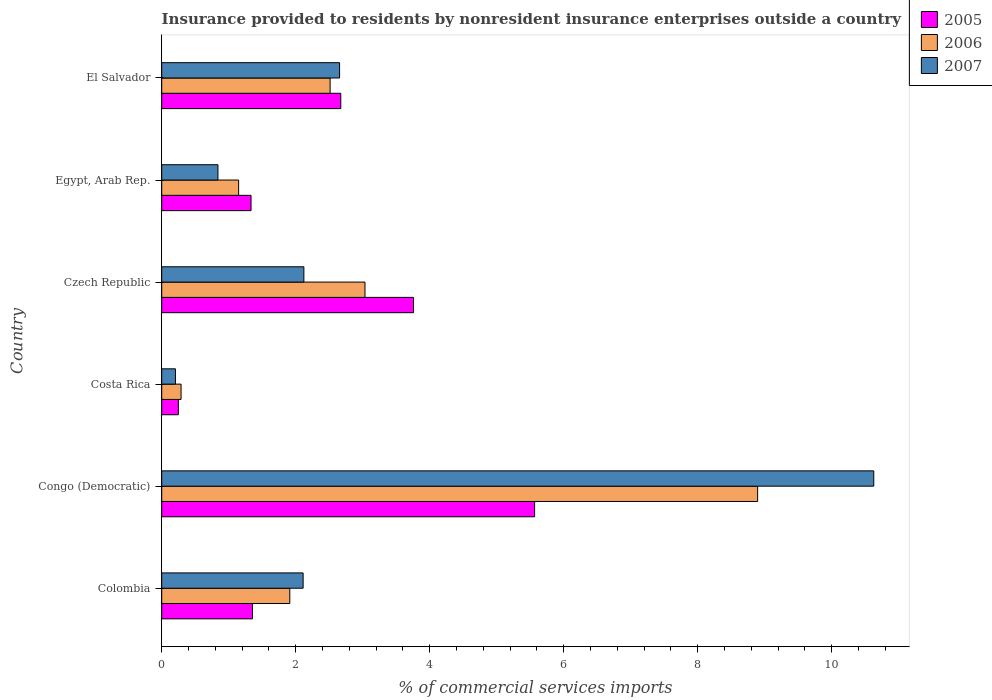How many different coloured bars are there?
Provide a succinct answer. 3. How many groups of bars are there?
Keep it short and to the point. 6. How many bars are there on the 5th tick from the top?
Give a very brief answer. 3. How many bars are there on the 6th tick from the bottom?
Make the answer very short. 3. What is the label of the 5th group of bars from the top?
Keep it short and to the point. Congo (Democratic). What is the Insurance provided to residents in 2005 in Costa Rica?
Keep it short and to the point. 0.25. Across all countries, what is the maximum Insurance provided to residents in 2007?
Your answer should be very brief. 10.63. Across all countries, what is the minimum Insurance provided to residents in 2006?
Ensure brevity in your answer.  0.29. In which country was the Insurance provided to residents in 2007 maximum?
Your answer should be very brief. Congo (Democratic). What is the total Insurance provided to residents in 2005 in the graph?
Offer a very short reply. 14.93. What is the difference between the Insurance provided to residents in 2006 in Colombia and that in Czech Republic?
Give a very brief answer. -1.12. What is the difference between the Insurance provided to residents in 2005 in Czech Republic and the Insurance provided to residents in 2006 in Congo (Democratic)?
Provide a succinct answer. -5.14. What is the average Insurance provided to residents in 2006 per country?
Offer a terse response. 2.96. What is the difference between the Insurance provided to residents in 2007 and Insurance provided to residents in 2006 in Egypt, Arab Rep.?
Ensure brevity in your answer.  -0.31. In how many countries, is the Insurance provided to residents in 2006 greater than 3.6 %?
Provide a short and direct response. 1. What is the ratio of the Insurance provided to residents in 2006 in Congo (Democratic) to that in El Salvador?
Provide a short and direct response. 3.54. What is the difference between the highest and the second highest Insurance provided to residents in 2006?
Give a very brief answer. 5.86. What is the difference between the highest and the lowest Insurance provided to residents in 2007?
Your answer should be compact. 10.42. In how many countries, is the Insurance provided to residents in 2005 greater than the average Insurance provided to residents in 2005 taken over all countries?
Provide a succinct answer. 3. What does the 2nd bar from the top in Egypt, Arab Rep. represents?
Provide a succinct answer. 2006. How many bars are there?
Make the answer very short. 18. How many countries are there in the graph?
Keep it short and to the point. 6. What is the difference between two consecutive major ticks on the X-axis?
Offer a terse response. 2. Are the values on the major ticks of X-axis written in scientific E-notation?
Provide a succinct answer. No. Does the graph contain grids?
Your response must be concise. No. Where does the legend appear in the graph?
Provide a succinct answer. Top right. How are the legend labels stacked?
Offer a very short reply. Vertical. What is the title of the graph?
Offer a very short reply. Insurance provided to residents by nonresident insurance enterprises outside a country. Does "1961" appear as one of the legend labels in the graph?
Your answer should be very brief. No. What is the label or title of the X-axis?
Your answer should be very brief. % of commercial services imports. What is the label or title of the Y-axis?
Provide a short and direct response. Country. What is the % of commercial services imports of 2005 in Colombia?
Your answer should be compact. 1.35. What is the % of commercial services imports of 2006 in Colombia?
Give a very brief answer. 1.91. What is the % of commercial services imports of 2007 in Colombia?
Ensure brevity in your answer.  2.11. What is the % of commercial services imports of 2005 in Congo (Democratic)?
Make the answer very short. 5.57. What is the % of commercial services imports in 2006 in Congo (Democratic)?
Make the answer very short. 8.89. What is the % of commercial services imports of 2007 in Congo (Democratic)?
Ensure brevity in your answer.  10.63. What is the % of commercial services imports of 2005 in Costa Rica?
Your response must be concise. 0.25. What is the % of commercial services imports of 2006 in Costa Rica?
Make the answer very short. 0.29. What is the % of commercial services imports of 2007 in Costa Rica?
Ensure brevity in your answer.  0.2. What is the % of commercial services imports in 2005 in Czech Republic?
Provide a short and direct response. 3.76. What is the % of commercial services imports in 2006 in Czech Republic?
Ensure brevity in your answer.  3.03. What is the % of commercial services imports in 2007 in Czech Republic?
Your answer should be very brief. 2.12. What is the % of commercial services imports of 2005 in Egypt, Arab Rep.?
Give a very brief answer. 1.33. What is the % of commercial services imports in 2006 in Egypt, Arab Rep.?
Make the answer very short. 1.15. What is the % of commercial services imports of 2007 in Egypt, Arab Rep.?
Your answer should be compact. 0.84. What is the % of commercial services imports in 2005 in El Salvador?
Your answer should be compact. 2.67. What is the % of commercial services imports in 2006 in El Salvador?
Provide a succinct answer. 2.51. What is the % of commercial services imports of 2007 in El Salvador?
Offer a very short reply. 2.65. Across all countries, what is the maximum % of commercial services imports of 2005?
Ensure brevity in your answer.  5.57. Across all countries, what is the maximum % of commercial services imports of 2006?
Your answer should be compact. 8.89. Across all countries, what is the maximum % of commercial services imports in 2007?
Offer a terse response. 10.63. Across all countries, what is the minimum % of commercial services imports in 2005?
Offer a very short reply. 0.25. Across all countries, what is the minimum % of commercial services imports of 2006?
Provide a succinct answer. 0.29. Across all countries, what is the minimum % of commercial services imports of 2007?
Provide a succinct answer. 0.2. What is the total % of commercial services imports in 2005 in the graph?
Offer a very short reply. 14.93. What is the total % of commercial services imports in 2006 in the graph?
Provide a short and direct response. 17.79. What is the total % of commercial services imports in 2007 in the graph?
Make the answer very short. 18.56. What is the difference between the % of commercial services imports of 2005 in Colombia and that in Congo (Democratic)?
Provide a succinct answer. -4.21. What is the difference between the % of commercial services imports in 2006 in Colombia and that in Congo (Democratic)?
Ensure brevity in your answer.  -6.98. What is the difference between the % of commercial services imports in 2007 in Colombia and that in Congo (Democratic)?
Offer a very short reply. -8.52. What is the difference between the % of commercial services imports in 2005 in Colombia and that in Costa Rica?
Provide a short and direct response. 1.11. What is the difference between the % of commercial services imports of 2006 in Colombia and that in Costa Rica?
Offer a very short reply. 1.62. What is the difference between the % of commercial services imports of 2007 in Colombia and that in Costa Rica?
Offer a very short reply. 1.91. What is the difference between the % of commercial services imports in 2005 in Colombia and that in Czech Republic?
Keep it short and to the point. -2.4. What is the difference between the % of commercial services imports of 2006 in Colombia and that in Czech Republic?
Your answer should be very brief. -1.12. What is the difference between the % of commercial services imports of 2007 in Colombia and that in Czech Republic?
Your answer should be compact. -0.01. What is the difference between the % of commercial services imports in 2005 in Colombia and that in Egypt, Arab Rep.?
Provide a succinct answer. 0.02. What is the difference between the % of commercial services imports of 2006 in Colombia and that in Egypt, Arab Rep.?
Your response must be concise. 0.76. What is the difference between the % of commercial services imports in 2007 in Colombia and that in Egypt, Arab Rep.?
Make the answer very short. 1.27. What is the difference between the % of commercial services imports of 2005 in Colombia and that in El Salvador?
Keep it short and to the point. -1.32. What is the difference between the % of commercial services imports of 2006 in Colombia and that in El Salvador?
Provide a succinct answer. -0.6. What is the difference between the % of commercial services imports of 2007 in Colombia and that in El Salvador?
Make the answer very short. -0.54. What is the difference between the % of commercial services imports in 2005 in Congo (Democratic) and that in Costa Rica?
Offer a terse response. 5.32. What is the difference between the % of commercial services imports of 2006 in Congo (Democratic) and that in Costa Rica?
Ensure brevity in your answer.  8.6. What is the difference between the % of commercial services imports of 2007 in Congo (Democratic) and that in Costa Rica?
Your answer should be compact. 10.42. What is the difference between the % of commercial services imports in 2005 in Congo (Democratic) and that in Czech Republic?
Keep it short and to the point. 1.81. What is the difference between the % of commercial services imports of 2006 in Congo (Democratic) and that in Czech Republic?
Provide a short and direct response. 5.86. What is the difference between the % of commercial services imports in 2007 in Congo (Democratic) and that in Czech Republic?
Your answer should be very brief. 8.51. What is the difference between the % of commercial services imports in 2005 in Congo (Democratic) and that in Egypt, Arab Rep.?
Provide a succinct answer. 4.23. What is the difference between the % of commercial services imports in 2006 in Congo (Democratic) and that in Egypt, Arab Rep.?
Your response must be concise. 7.75. What is the difference between the % of commercial services imports in 2007 in Congo (Democratic) and that in Egypt, Arab Rep.?
Provide a succinct answer. 9.79. What is the difference between the % of commercial services imports of 2005 in Congo (Democratic) and that in El Salvador?
Give a very brief answer. 2.89. What is the difference between the % of commercial services imports of 2006 in Congo (Democratic) and that in El Salvador?
Your response must be concise. 6.38. What is the difference between the % of commercial services imports of 2007 in Congo (Democratic) and that in El Salvador?
Keep it short and to the point. 7.97. What is the difference between the % of commercial services imports of 2005 in Costa Rica and that in Czech Republic?
Offer a very short reply. -3.51. What is the difference between the % of commercial services imports in 2006 in Costa Rica and that in Czech Republic?
Your answer should be compact. -2.75. What is the difference between the % of commercial services imports of 2007 in Costa Rica and that in Czech Republic?
Give a very brief answer. -1.92. What is the difference between the % of commercial services imports in 2005 in Costa Rica and that in Egypt, Arab Rep.?
Make the answer very short. -1.08. What is the difference between the % of commercial services imports of 2006 in Costa Rica and that in Egypt, Arab Rep.?
Provide a succinct answer. -0.86. What is the difference between the % of commercial services imports in 2007 in Costa Rica and that in Egypt, Arab Rep.?
Your answer should be very brief. -0.63. What is the difference between the % of commercial services imports in 2005 in Costa Rica and that in El Salvador?
Ensure brevity in your answer.  -2.42. What is the difference between the % of commercial services imports in 2006 in Costa Rica and that in El Salvador?
Your answer should be compact. -2.22. What is the difference between the % of commercial services imports of 2007 in Costa Rica and that in El Salvador?
Keep it short and to the point. -2.45. What is the difference between the % of commercial services imports in 2005 in Czech Republic and that in Egypt, Arab Rep.?
Provide a succinct answer. 2.42. What is the difference between the % of commercial services imports of 2006 in Czech Republic and that in Egypt, Arab Rep.?
Offer a very short reply. 1.89. What is the difference between the % of commercial services imports of 2007 in Czech Republic and that in Egypt, Arab Rep.?
Make the answer very short. 1.28. What is the difference between the % of commercial services imports of 2005 in Czech Republic and that in El Salvador?
Ensure brevity in your answer.  1.09. What is the difference between the % of commercial services imports in 2006 in Czech Republic and that in El Salvador?
Your answer should be very brief. 0.52. What is the difference between the % of commercial services imports in 2007 in Czech Republic and that in El Salvador?
Your answer should be very brief. -0.53. What is the difference between the % of commercial services imports of 2005 in Egypt, Arab Rep. and that in El Salvador?
Ensure brevity in your answer.  -1.34. What is the difference between the % of commercial services imports in 2006 in Egypt, Arab Rep. and that in El Salvador?
Your answer should be compact. -1.37. What is the difference between the % of commercial services imports in 2007 in Egypt, Arab Rep. and that in El Salvador?
Your answer should be compact. -1.82. What is the difference between the % of commercial services imports of 2005 in Colombia and the % of commercial services imports of 2006 in Congo (Democratic)?
Provide a short and direct response. -7.54. What is the difference between the % of commercial services imports of 2005 in Colombia and the % of commercial services imports of 2007 in Congo (Democratic)?
Your answer should be very brief. -9.27. What is the difference between the % of commercial services imports in 2006 in Colombia and the % of commercial services imports in 2007 in Congo (Democratic)?
Your answer should be very brief. -8.72. What is the difference between the % of commercial services imports of 2005 in Colombia and the % of commercial services imports of 2006 in Costa Rica?
Provide a short and direct response. 1.07. What is the difference between the % of commercial services imports of 2005 in Colombia and the % of commercial services imports of 2007 in Costa Rica?
Your answer should be compact. 1.15. What is the difference between the % of commercial services imports in 2006 in Colombia and the % of commercial services imports in 2007 in Costa Rica?
Give a very brief answer. 1.71. What is the difference between the % of commercial services imports of 2005 in Colombia and the % of commercial services imports of 2006 in Czech Republic?
Provide a short and direct response. -1.68. What is the difference between the % of commercial services imports in 2005 in Colombia and the % of commercial services imports in 2007 in Czech Republic?
Your response must be concise. -0.77. What is the difference between the % of commercial services imports of 2006 in Colombia and the % of commercial services imports of 2007 in Czech Republic?
Give a very brief answer. -0.21. What is the difference between the % of commercial services imports of 2005 in Colombia and the % of commercial services imports of 2006 in Egypt, Arab Rep.?
Make the answer very short. 0.21. What is the difference between the % of commercial services imports of 2005 in Colombia and the % of commercial services imports of 2007 in Egypt, Arab Rep.?
Offer a terse response. 0.52. What is the difference between the % of commercial services imports of 2006 in Colombia and the % of commercial services imports of 2007 in Egypt, Arab Rep.?
Offer a very short reply. 1.07. What is the difference between the % of commercial services imports in 2005 in Colombia and the % of commercial services imports in 2006 in El Salvador?
Keep it short and to the point. -1.16. What is the difference between the % of commercial services imports in 2005 in Colombia and the % of commercial services imports in 2007 in El Salvador?
Keep it short and to the point. -1.3. What is the difference between the % of commercial services imports of 2006 in Colombia and the % of commercial services imports of 2007 in El Salvador?
Your answer should be compact. -0.74. What is the difference between the % of commercial services imports of 2005 in Congo (Democratic) and the % of commercial services imports of 2006 in Costa Rica?
Your response must be concise. 5.28. What is the difference between the % of commercial services imports of 2005 in Congo (Democratic) and the % of commercial services imports of 2007 in Costa Rica?
Your answer should be very brief. 5.36. What is the difference between the % of commercial services imports in 2006 in Congo (Democratic) and the % of commercial services imports in 2007 in Costa Rica?
Your answer should be very brief. 8.69. What is the difference between the % of commercial services imports in 2005 in Congo (Democratic) and the % of commercial services imports in 2006 in Czech Republic?
Give a very brief answer. 2.53. What is the difference between the % of commercial services imports in 2005 in Congo (Democratic) and the % of commercial services imports in 2007 in Czech Republic?
Make the answer very short. 3.44. What is the difference between the % of commercial services imports in 2006 in Congo (Democratic) and the % of commercial services imports in 2007 in Czech Republic?
Your answer should be very brief. 6.77. What is the difference between the % of commercial services imports of 2005 in Congo (Democratic) and the % of commercial services imports of 2006 in Egypt, Arab Rep.?
Keep it short and to the point. 4.42. What is the difference between the % of commercial services imports of 2005 in Congo (Democratic) and the % of commercial services imports of 2007 in Egypt, Arab Rep.?
Provide a succinct answer. 4.73. What is the difference between the % of commercial services imports in 2006 in Congo (Democratic) and the % of commercial services imports in 2007 in Egypt, Arab Rep.?
Offer a very short reply. 8.05. What is the difference between the % of commercial services imports in 2005 in Congo (Democratic) and the % of commercial services imports in 2006 in El Salvador?
Make the answer very short. 3.05. What is the difference between the % of commercial services imports of 2005 in Congo (Democratic) and the % of commercial services imports of 2007 in El Salvador?
Provide a short and direct response. 2.91. What is the difference between the % of commercial services imports of 2006 in Congo (Democratic) and the % of commercial services imports of 2007 in El Salvador?
Offer a very short reply. 6.24. What is the difference between the % of commercial services imports in 2005 in Costa Rica and the % of commercial services imports in 2006 in Czech Republic?
Provide a succinct answer. -2.79. What is the difference between the % of commercial services imports in 2005 in Costa Rica and the % of commercial services imports in 2007 in Czech Republic?
Make the answer very short. -1.87. What is the difference between the % of commercial services imports of 2006 in Costa Rica and the % of commercial services imports of 2007 in Czech Republic?
Offer a terse response. -1.83. What is the difference between the % of commercial services imports of 2005 in Costa Rica and the % of commercial services imports of 2006 in Egypt, Arab Rep.?
Your answer should be compact. -0.9. What is the difference between the % of commercial services imports in 2005 in Costa Rica and the % of commercial services imports in 2007 in Egypt, Arab Rep.?
Offer a very short reply. -0.59. What is the difference between the % of commercial services imports in 2006 in Costa Rica and the % of commercial services imports in 2007 in Egypt, Arab Rep.?
Make the answer very short. -0.55. What is the difference between the % of commercial services imports in 2005 in Costa Rica and the % of commercial services imports in 2006 in El Salvador?
Make the answer very short. -2.26. What is the difference between the % of commercial services imports in 2005 in Costa Rica and the % of commercial services imports in 2007 in El Salvador?
Your answer should be compact. -2.41. What is the difference between the % of commercial services imports in 2006 in Costa Rica and the % of commercial services imports in 2007 in El Salvador?
Make the answer very short. -2.37. What is the difference between the % of commercial services imports in 2005 in Czech Republic and the % of commercial services imports in 2006 in Egypt, Arab Rep.?
Ensure brevity in your answer.  2.61. What is the difference between the % of commercial services imports in 2005 in Czech Republic and the % of commercial services imports in 2007 in Egypt, Arab Rep.?
Give a very brief answer. 2.92. What is the difference between the % of commercial services imports of 2006 in Czech Republic and the % of commercial services imports of 2007 in Egypt, Arab Rep.?
Your answer should be very brief. 2.19. What is the difference between the % of commercial services imports in 2005 in Czech Republic and the % of commercial services imports in 2006 in El Salvador?
Your response must be concise. 1.24. What is the difference between the % of commercial services imports of 2005 in Czech Republic and the % of commercial services imports of 2007 in El Salvador?
Ensure brevity in your answer.  1.1. What is the difference between the % of commercial services imports of 2006 in Czech Republic and the % of commercial services imports of 2007 in El Salvador?
Ensure brevity in your answer.  0.38. What is the difference between the % of commercial services imports of 2005 in Egypt, Arab Rep. and the % of commercial services imports of 2006 in El Salvador?
Your answer should be very brief. -1.18. What is the difference between the % of commercial services imports of 2005 in Egypt, Arab Rep. and the % of commercial services imports of 2007 in El Salvador?
Ensure brevity in your answer.  -1.32. What is the difference between the % of commercial services imports in 2006 in Egypt, Arab Rep. and the % of commercial services imports in 2007 in El Salvador?
Your response must be concise. -1.51. What is the average % of commercial services imports in 2005 per country?
Keep it short and to the point. 2.49. What is the average % of commercial services imports of 2006 per country?
Offer a terse response. 2.96. What is the average % of commercial services imports in 2007 per country?
Provide a succinct answer. 3.09. What is the difference between the % of commercial services imports of 2005 and % of commercial services imports of 2006 in Colombia?
Make the answer very short. -0.56. What is the difference between the % of commercial services imports in 2005 and % of commercial services imports in 2007 in Colombia?
Your answer should be compact. -0.76. What is the difference between the % of commercial services imports of 2006 and % of commercial services imports of 2007 in Colombia?
Offer a terse response. -0.2. What is the difference between the % of commercial services imports of 2005 and % of commercial services imports of 2006 in Congo (Democratic)?
Ensure brevity in your answer.  -3.33. What is the difference between the % of commercial services imports of 2005 and % of commercial services imports of 2007 in Congo (Democratic)?
Ensure brevity in your answer.  -5.06. What is the difference between the % of commercial services imports of 2006 and % of commercial services imports of 2007 in Congo (Democratic)?
Provide a succinct answer. -1.73. What is the difference between the % of commercial services imports of 2005 and % of commercial services imports of 2006 in Costa Rica?
Ensure brevity in your answer.  -0.04. What is the difference between the % of commercial services imports in 2005 and % of commercial services imports in 2007 in Costa Rica?
Make the answer very short. 0.04. What is the difference between the % of commercial services imports of 2006 and % of commercial services imports of 2007 in Costa Rica?
Give a very brief answer. 0.08. What is the difference between the % of commercial services imports of 2005 and % of commercial services imports of 2006 in Czech Republic?
Provide a succinct answer. 0.72. What is the difference between the % of commercial services imports in 2005 and % of commercial services imports in 2007 in Czech Republic?
Provide a short and direct response. 1.64. What is the difference between the % of commercial services imports in 2006 and % of commercial services imports in 2007 in Czech Republic?
Ensure brevity in your answer.  0.91. What is the difference between the % of commercial services imports in 2005 and % of commercial services imports in 2006 in Egypt, Arab Rep.?
Keep it short and to the point. 0.19. What is the difference between the % of commercial services imports of 2005 and % of commercial services imports of 2007 in Egypt, Arab Rep.?
Offer a terse response. 0.49. What is the difference between the % of commercial services imports in 2006 and % of commercial services imports in 2007 in Egypt, Arab Rep.?
Offer a terse response. 0.31. What is the difference between the % of commercial services imports of 2005 and % of commercial services imports of 2006 in El Salvador?
Give a very brief answer. 0.16. What is the difference between the % of commercial services imports of 2005 and % of commercial services imports of 2007 in El Salvador?
Offer a terse response. 0.02. What is the difference between the % of commercial services imports of 2006 and % of commercial services imports of 2007 in El Salvador?
Make the answer very short. -0.14. What is the ratio of the % of commercial services imports in 2005 in Colombia to that in Congo (Democratic)?
Keep it short and to the point. 0.24. What is the ratio of the % of commercial services imports of 2006 in Colombia to that in Congo (Democratic)?
Give a very brief answer. 0.21. What is the ratio of the % of commercial services imports of 2007 in Colombia to that in Congo (Democratic)?
Keep it short and to the point. 0.2. What is the ratio of the % of commercial services imports in 2005 in Colombia to that in Costa Rica?
Ensure brevity in your answer.  5.45. What is the ratio of the % of commercial services imports of 2006 in Colombia to that in Costa Rica?
Your answer should be very brief. 6.62. What is the ratio of the % of commercial services imports of 2007 in Colombia to that in Costa Rica?
Your response must be concise. 10.3. What is the ratio of the % of commercial services imports in 2005 in Colombia to that in Czech Republic?
Your response must be concise. 0.36. What is the ratio of the % of commercial services imports of 2006 in Colombia to that in Czech Republic?
Your response must be concise. 0.63. What is the ratio of the % of commercial services imports of 2007 in Colombia to that in Czech Republic?
Your answer should be compact. 0.99. What is the ratio of the % of commercial services imports in 2005 in Colombia to that in Egypt, Arab Rep.?
Your answer should be very brief. 1.02. What is the ratio of the % of commercial services imports of 2006 in Colombia to that in Egypt, Arab Rep.?
Give a very brief answer. 1.67. What is the ratio of the % of commercial services imports of 2007 in Colombia to that in Egypt, Arab Rep.?
Your answer should be compact. 2.51. What is the ratio of the % of commercial services imports of 2005 in Colombia to that in El Salvador?
Offer a very short reply. 0.51. What is the ratio of the % of commercial services imports in 2006 in Colombia to that in El Salvador?
Give a very brief answer. 0.76. What is the ratio of the % of commercial services imports of 2007 in Colombia to that in El Salvador?
Offer a terse response. 0.8. What is the ratio of the % of commercial services imports of 2005 in Congo (Democratic) to that in Costa Rica?
Provide a succinct answer. 22.41. What is the ratio of the % of commercial services imports of 2006 in Congo (Democratic) to that in Costa Rica?
Make the answer very short. 30.8. What is the ratio of the % of commercial services imports of 2007 in Congo (Democratic) to that in Costa Rica?
Make the answer very short. 51.87. What is the ratio of the % of commercial services imports in 2005 in Congo (Democratic) to that in Czech Republic?
Provide a succinct answer. 1.48. What is the ratio of the % of commercial services imports of 2006 in Congo (Democratic) to that in Czech Republic?
Keep it short and to the point. 2.93. What is the ratio of the % of commercial services imports of 2007 in Congo (Democratic) to that in Czech Republic?
Your answer should be compact. 5.01. What is the ratio of the % of commercial services imports in 2005 in Congo (Democratic) to that in Egypt, Arab Rep.?
Your answer should be compact. 4.17. What is the ratio of the % of commercial services imports of 2006 in Congo (Democratic) to that in Egypt, Arab Rep.?
Your response must be concise. 7.75. What is the ratio of the % of commercial services imports of 2007 in Congo (Democratic) to that in Egypt, Arab Rep.?
Your answer should be compact. 12.66. What is the ratio of the % of commercial services imports in 2005 in Congo (Democratic) to that in El Salvador?
Ensure brevity in your answer.  2.08. What is the ratio of the % of commercial services imports in 2006 in Congo (Democratic) to that in El Salvador?
Offer a very short reply. 3.54. What is the ratio of the % of commercial services imports of 2007 in Congo (Democratic) to that in El Salvador?
Your answer should be very brief. 4. What is the ratio of the % of commercial services imports in 2005 in Costa Rica to that in Czech Republic?
Ensure brevity in your answer.  0.07. What is the ratio of the % of commercial services imports in 2006 in Costa Rica to that in Czech Republic?
Give a very brief answer. 0.1. What is the ratio of the % of commercial services imports in 2007 in Costa Rica to that in Czech Republic?
Your answer should be compact. 0.1. What is the ratio of the % of commercial services imports in 2005 in Costa Rica to that in Egypt, Arab Rep.?
Your response must be concise. 0.19. What is the ratio of the % of commercial services imports in 2006 in Costa Rica to that in Egypt, Arab Rep.?
Provide a succinct answer. 0.25. What is the ratio of the % of commercial services imports of 2007 in Costa Rica to that in Egypt, Arab Rep.?
Provide a short and direct response. 0.24. What is the ratio of the % of commercial services imports of 2005 in Costa Rica to that in El Salvador?
Your response must be concise. 0.09. What is the ratio of the % of commercial services imports of 2006 in Costa Rica to that in El Salvador?
Offer a very short reply. 0.11. What is the ratio of the % of commercial services imports in 2007 in Costa Rica to that in El Salvador?
Keep it short and to the point. 0.08. What is the ratio of the % of commercial services imports of 2005 in Czech Republic to that in Egypt, Arab Rep.?
Offer a very short reply. 2.82. What is the ratio of the % of commercial services imports in 2006 in Czech Republic to that in Egypt, Arab Rep.?
Offer a terse response. 2.64. What is the ratio of the % of commercial services imports of 2007 in Czech Republic to that in Egypt, Arab Rep.?
Provide a short and direct response. 2.53. What is the ratio of the % of commercial services imports of 2005 in Czech Republic to that in El Salvador?
Keep it short and to the point. 1.41. What is the ratio of the % of commercial services imports in 2006 in Czech Republic to that in El Salvador?
Your response must be concise. 1.21. What is the ratio of the % of commercial services imports of 2007 in Czech Republic to that in El Salvador?
Offer a terse response. 0.8. What is the ratio of the % of commercial services imports of 2005 in Egypt, Arab Rep. to that in El Salvador?
Keep it short and to the point. 0.5. What is the ratio of the % of commercial services imports in 2006 in Egypt, Arab Rep. to that in El Salvador?
Keep it short and to the point. 0.46. What is the ratio of the % of commercial services imports of 2007 in Egypt, Arab Rep. to that in El Salvador?
Provide a short and direct response. 0.32. What is the difference between the highest and the second highest % of commercial services imports of 2005?
Offer a very short reply. 1.81. What is the difference between the highest and the second highest % of commercial services imports in 2006?
Your response must be concise. 5.86. What is the difference between the highest and the second highest % of commercial services imports of 2007?
Your response must be concise. 7.97. What is the difference between the highest and the lowest % of commercial services imports of 2005?
Make the answer very short. 5.32. What is the difference between the highest and the lowest % of commercial services imports in 2006?
Provide a succinct answer. 8.6. What is the difference between the highest and the lowest % of commercial services imports of 2007?
Provide a succinct answer. 10.42. 